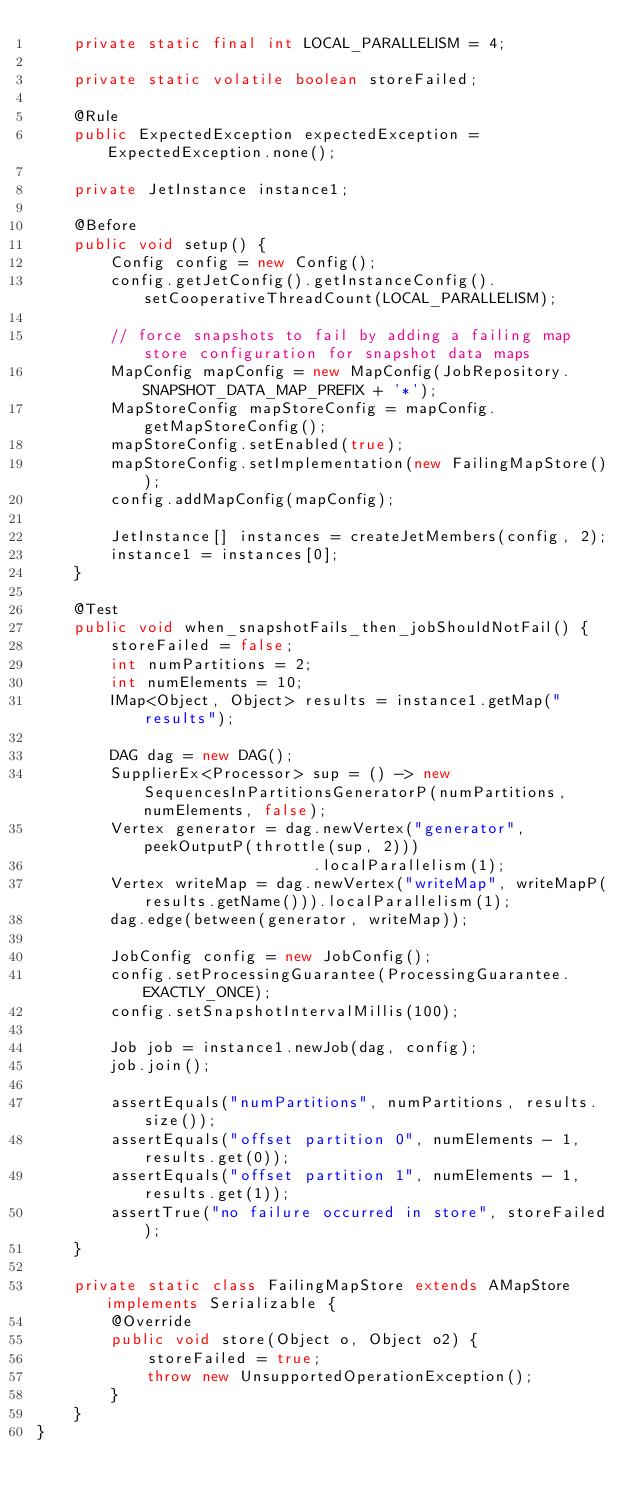<code> <loc_0><loc_0><loc_500><loc_500><_Java_>    private static final int LOCAL_PARALLELISM = 4;

    private static volatile boolean storeFailed;

    @Rule
    public ExpectedException expectedException = ExpectedException.none();

    private JetInstance instance1;

    @Before
    public void setup() {
        Config config = new Config();
        config.getJetConfig().getInstanceConfig().setCooperativeThreadCount(LOCAL_PARALLELISM);

        // force snapshots to fail by adding a failing map store configuration for snapshot data maps
        MapConfig mapConfig = new MapConfig(JobRepository.SNAPSHOT_DATA_MAP_PREFIX + '*');
        MapStoreConfig mapStoreConfig = mapConfig.getMapStoreConfig();
        mapStoreConfig.setEnabled(true);
        mapStoreConfig.setImplementation(new FailingMapStore());
        config.addMapConfig(mapConfig);

        JetInstance[] instances = createJetMembers(config, 2);
        instance1 = instances[0];
    }

    @Test
    public void when_snapshotFails_then_jobShouldNotFail() {
        storeFailed = false;
        int numPartitions = 2;
        int numElements = 10;
        IMap<Object, Object> results = instance1.getMap("results");

        DAG dag = new DAG();
        SupplierEx<Processor> sup = () -> new SequencesInPartitionsGeneratorP(numPartitions, numElements, false);
        Vertex generator = dag.newVertex("generator", peekOutputP(throttle(sup, 2)))
                              .localParallelism(1);
        Vertex writeMap = dag.newVertex("writeMap", writeMapP(results.getName())).localParallelism(1);
        dag.edge(between(generator, writeMap));

        JobConfig config = new JobConfig();
        config.setProcessingGuarantee(ProcessingGuarantee.EXACTLY_ONCE);
        config.setSnapshotIntervalMillis(100);

        Job job = instance1.newJob(dag, config);
        job.join();

        assertEquals("numPartitions", numPartitions, results.size());
        assertEquals("offset partition 0", numElements - 1, results.get(0));
        assertEquals("offset partition 1", numElements - 1, results.get(1));
        assertTrue("no failure occurred in store", storeFailed);
    }

    private static class FailingMapStore extends AMapStore implements Serializable {
        @Override
        public void store(Object o, Object o2) {
            storeFailed = true;
            throw new UnsupportedOperationException();
        }
    }
}
</code> 